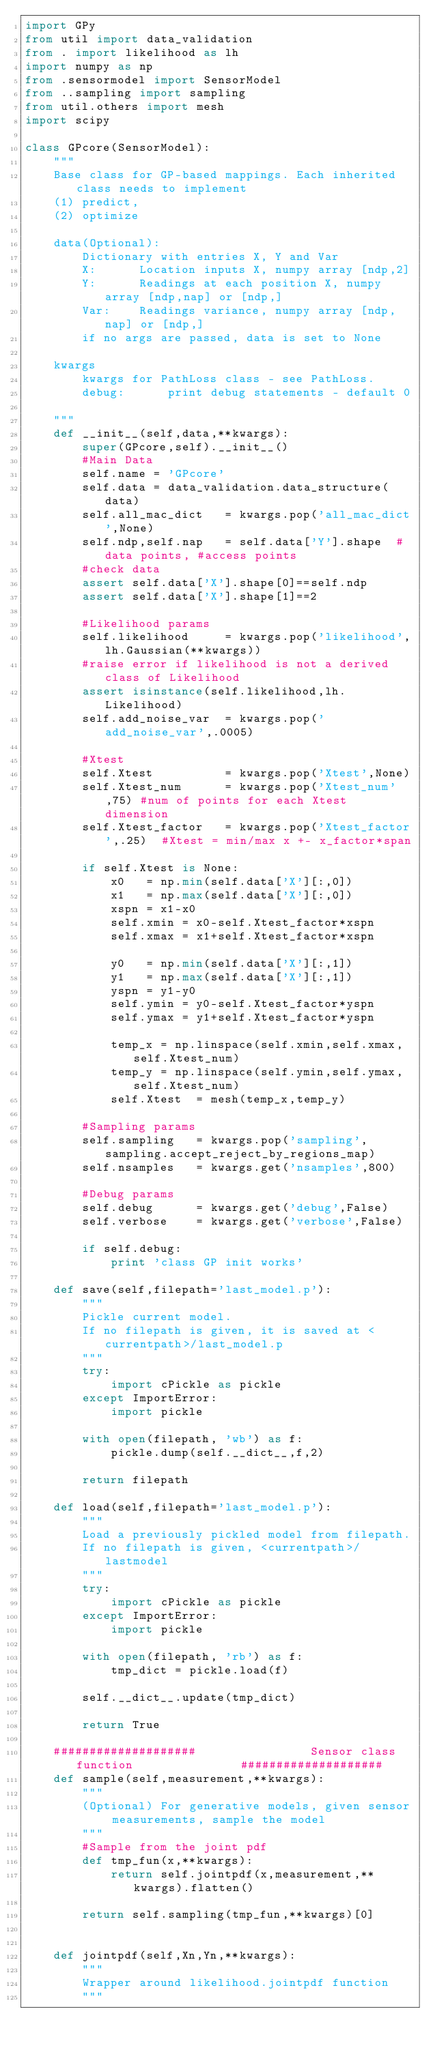Convert code to text. <code><loc_0><loc_0><loc_500><loc_500><_Python_>import GPy
from util import data_validation 
from . import likelihood as lh
import numpy as np
from .sensormodel import SensorModel
from ..sampling import sampling
from util.others import mesh
import scipy

class GPcore(SensorModel):   
    """
    Base class for GP-based mappings. Each inherited class needs to implement
    (1) predict,
    (2) optimize  

    data(Optional):
        Dictionary with entries X, Y and Var
        X:      Location inputs X, numpy array [ndp,2]
        Y:      Readings at each position X, numpy array [ndp,nap] or [ndp,]
        Var:    Readings variance, numpy array [ndp,nap] or [ndp,]
        if no args are passed, data is set to None

    kwargs
        kwargs for PathLoss class - see PathLoss.
        debug:      print debug statements - default 0

    """
    def __init__(self,data,**kwargs):
        super(GPcore,self).__init__()
        #Main Data
        self.name = 'GPcore'        
        self.data = data_validation.data_structure(data)
        self.all_mac_dict   = kwargs.pop('all_mac_dict',None)
        self.ndp,self.nap   = self.data['Y'].shape  #data points, #access points
        #check data
        assert self.data['X'].shape[0]==self.ndp
        assert self.data['X'].shape[1]==2

        #Likelihood params        
        self.likelihood     = kwargs.pop('likelihood',lh.Gaussian(**kwargs))
        #raise error if likelihood is not a derived class of Likelihood
        assert isinstance(self.likelihood,lh.Likelihood)
        self.add_noise_var  = kwargs.pop('add_noise_var',.0005)

        #Xtest
        self.Xtest          = kwargs.pop('Xtest',None) 
        self.Xtest_num      = kwargs.pop('Xtest_num',75) #num of points for each Xtest dimension
        self.Xtest_factor   = kwargs.pop('Xtest_factor',.25)  #Xtest = min/max x +- x_factor*span

        if self.Xtest is None:
            x0   = np.min(self.data['X'][:,0])
            x1   = np.max(self.data['X'][:,0])
            xspn = x1-x0
            self.xmin = x0-self.Xtest_factor*xspn
            self.xmax = x1+self.Xtest_factor*xspn

            y0   = np.min(self.data['X'][:,1])
            y1   = np.max(self.data['X'][:,1])
            yspn = y1-y0
            self.ymin = y0-self.Xtest_factor*yspn
            self.ymax = y1+self.Xtest_factor*yspn

            temp_x = np.linspace(self.xmin,self.xmax,self.Xtest_num)
            temp_y = np.linspace(self.ymin,self.ymax,self.Xtest_num)
            self.Xtest  = mesh(temp_x,temp_y)

        #Sampling params
        self.sampling   = kwargs.pop('sampling',sampling.accept_reject_by_regions_map)
        self.nsamples   = kwargs.get('nsamples',800)

        #Debug params                
        self.debug      = kwargs.get('debug',False)     
        self.verbose    = kwargs.get('verbose',False)    

        if self.debug:
            print 'class GP init works'
     
    def save(self,filepath='last_model.p'):
        """
        Pickle current model. 
        If no filepath is given, it is saved at <currentpath>/last_model.p
        """
        try: 
            import cPickle as pickle
        except ImportError:
            import pickle

        with open(filepath, 'wb') as f:
            pickle.dump(self.__dict__,f,2)
        
        return filepath

    def load(self,filepath='last_model.p'):
        """
        Load a previously pickled model from filepath. 
        If no filepath is given, <currentpath>/lastmodel
        """
        try: 
            import cPickle as pickle
        except ImportError:
            import pickle

        with open(filepath, 'rb') as f:
            tmp_dict = pickle.load(f)
        
        self.__dict__.update(tmp_dict)        
        
        return True

    ####################                Sensor class function               ####################
    def sample(self,measurement,**kwargs):
        """
        (Optional) For generative models, given sensor measurements, sample the model 
        """
        #Sample from the joint pdf
        def tmp_fun(x,**kwargs):
            return self.jointpdf(x,measurement,**kwargs).flatten()
        
        return self.sampling(tmp_fun,**kwargs)[0]

    
    def jointpdf(self,Xn,Yn,**kwargs):
        """
        Wrapper around likelihood.jointpdf function
        """</code> 